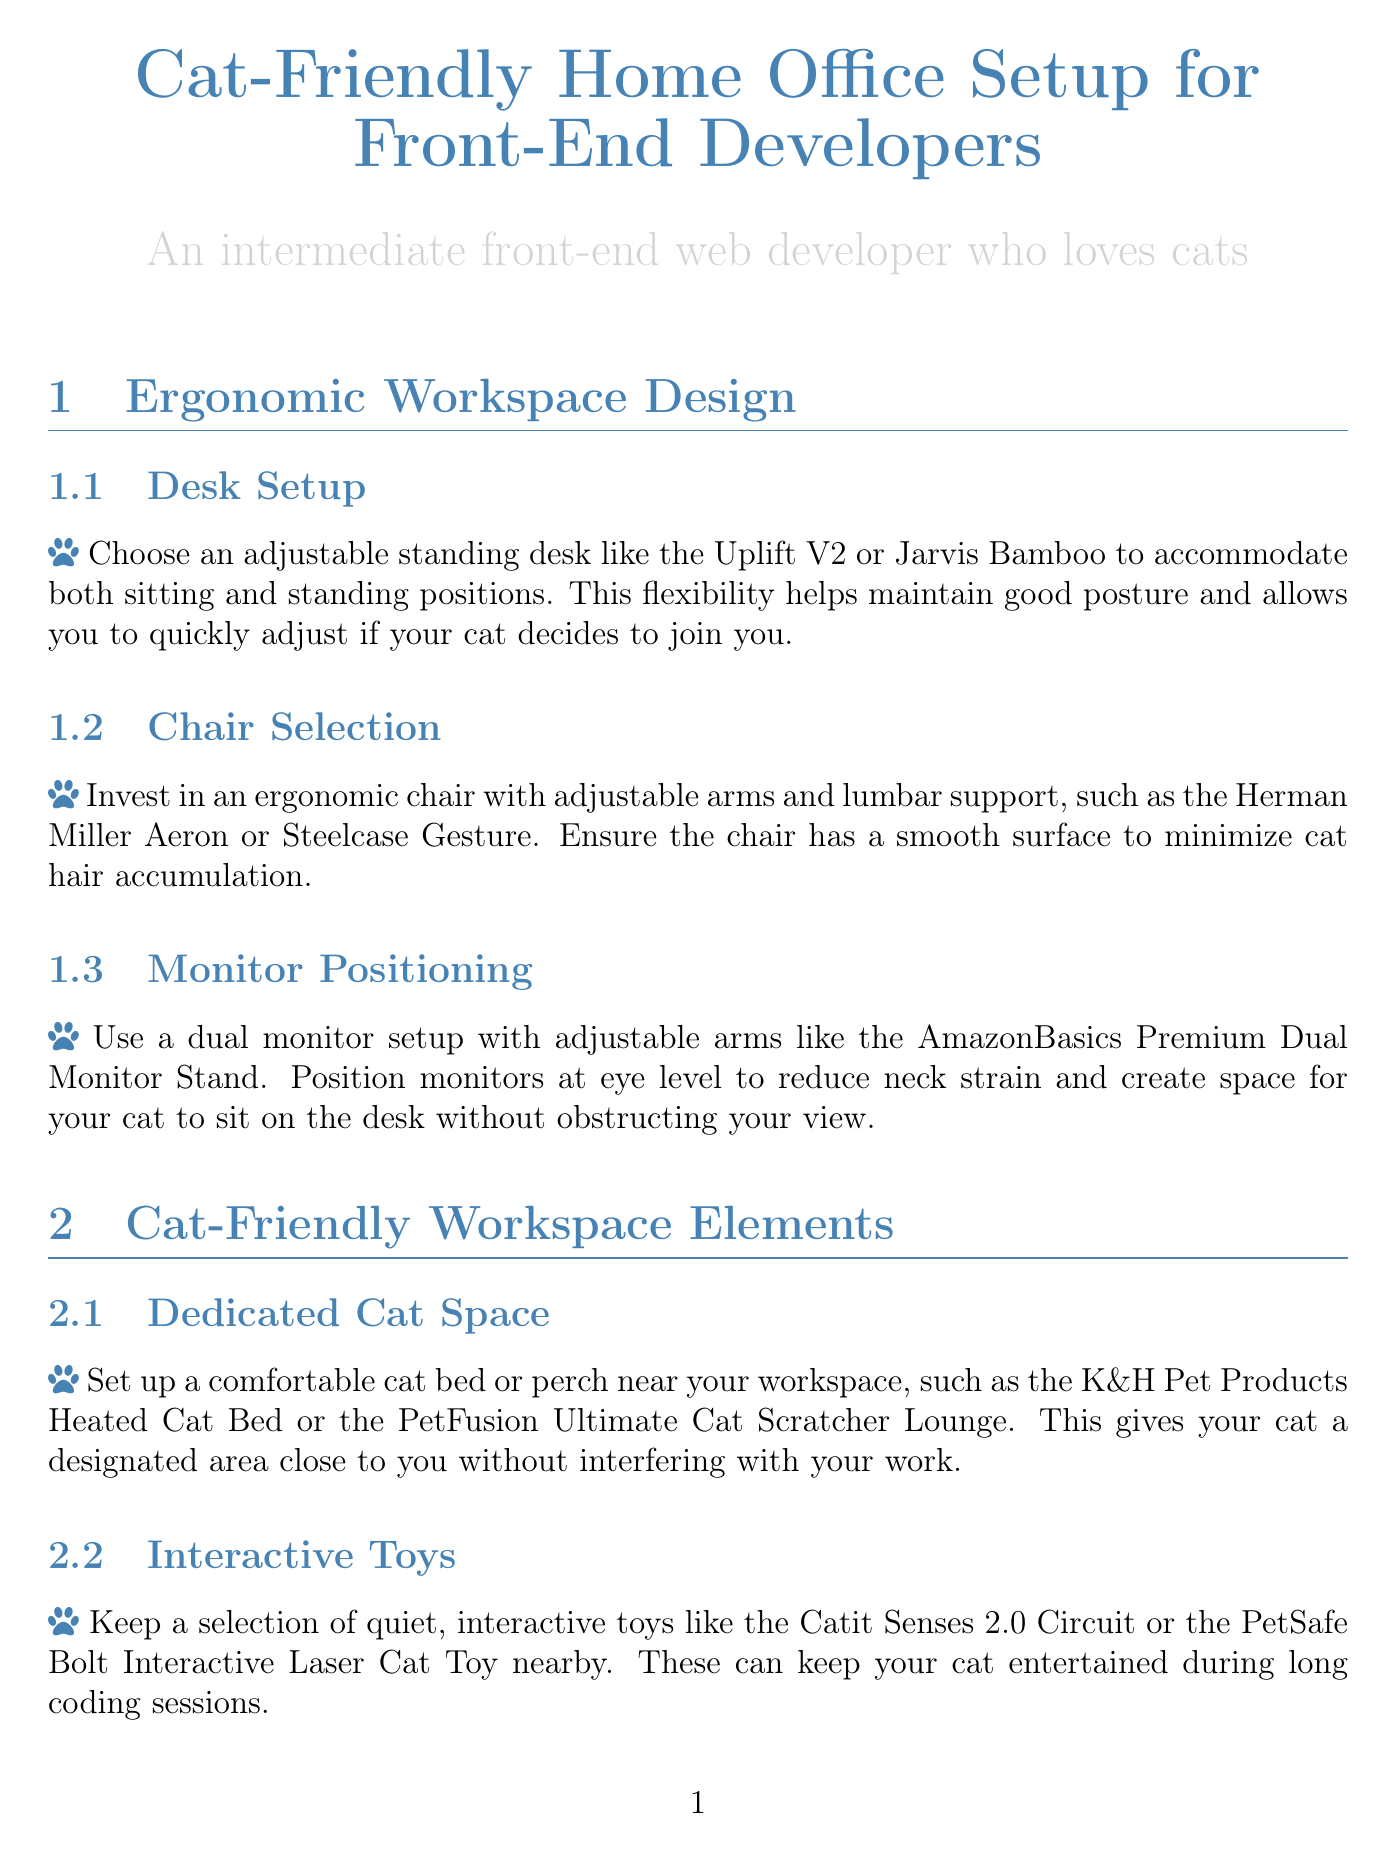what is the title of the document? The title is stated at the beginning of the document, presenting the main focus of the content.
Answer: Cat-Friendly Home Office Setup for Front-End Developers which desk is recommended for an ergonomic workspace? The document specifically suggests an adjustable standing desk that supports good posture.
Answer: Uplift V2 or Jarvis Bamboo what type of headphones is suggested for noise reduction? The section on minimizing distractions mentions specific brands of headphones to reduce distractions from cat noises.
Answer: Sony WH-1000XM4 or Bose QuietComfort 35 II what is a recommended method to manage hair control? The document provides a tip for quick cleanup of cat hair in the workspace.
Answer: Handheld vacuum which app can be used for scheduled play breaks? This document references apps that help remind users to take breaks for playing with their cats.
Answer: Forest or Pomofocus what cat-friendly item is suggested for feeding? The recommended item is aimed at reducing interruptions during work hours related to feeding the cat.
Answer: Automatic cat feeder how should monitors be positioned to reduce neck strain? The document gives advice on monitor positioning to ensure they are at a certain level for comfort and utility.
Answer: Eye level what is the purpose of using a silicone keyboard cover? The document outlines a specific function that the silicone keyboard cover serves in the workspace.
Answer: Protect keyboard from cat hair what scratching solution is recommended? This section discusses how to address scratching behavior of cats in the workspace.
Answer: SmartCat Ultimate Scratching Post 